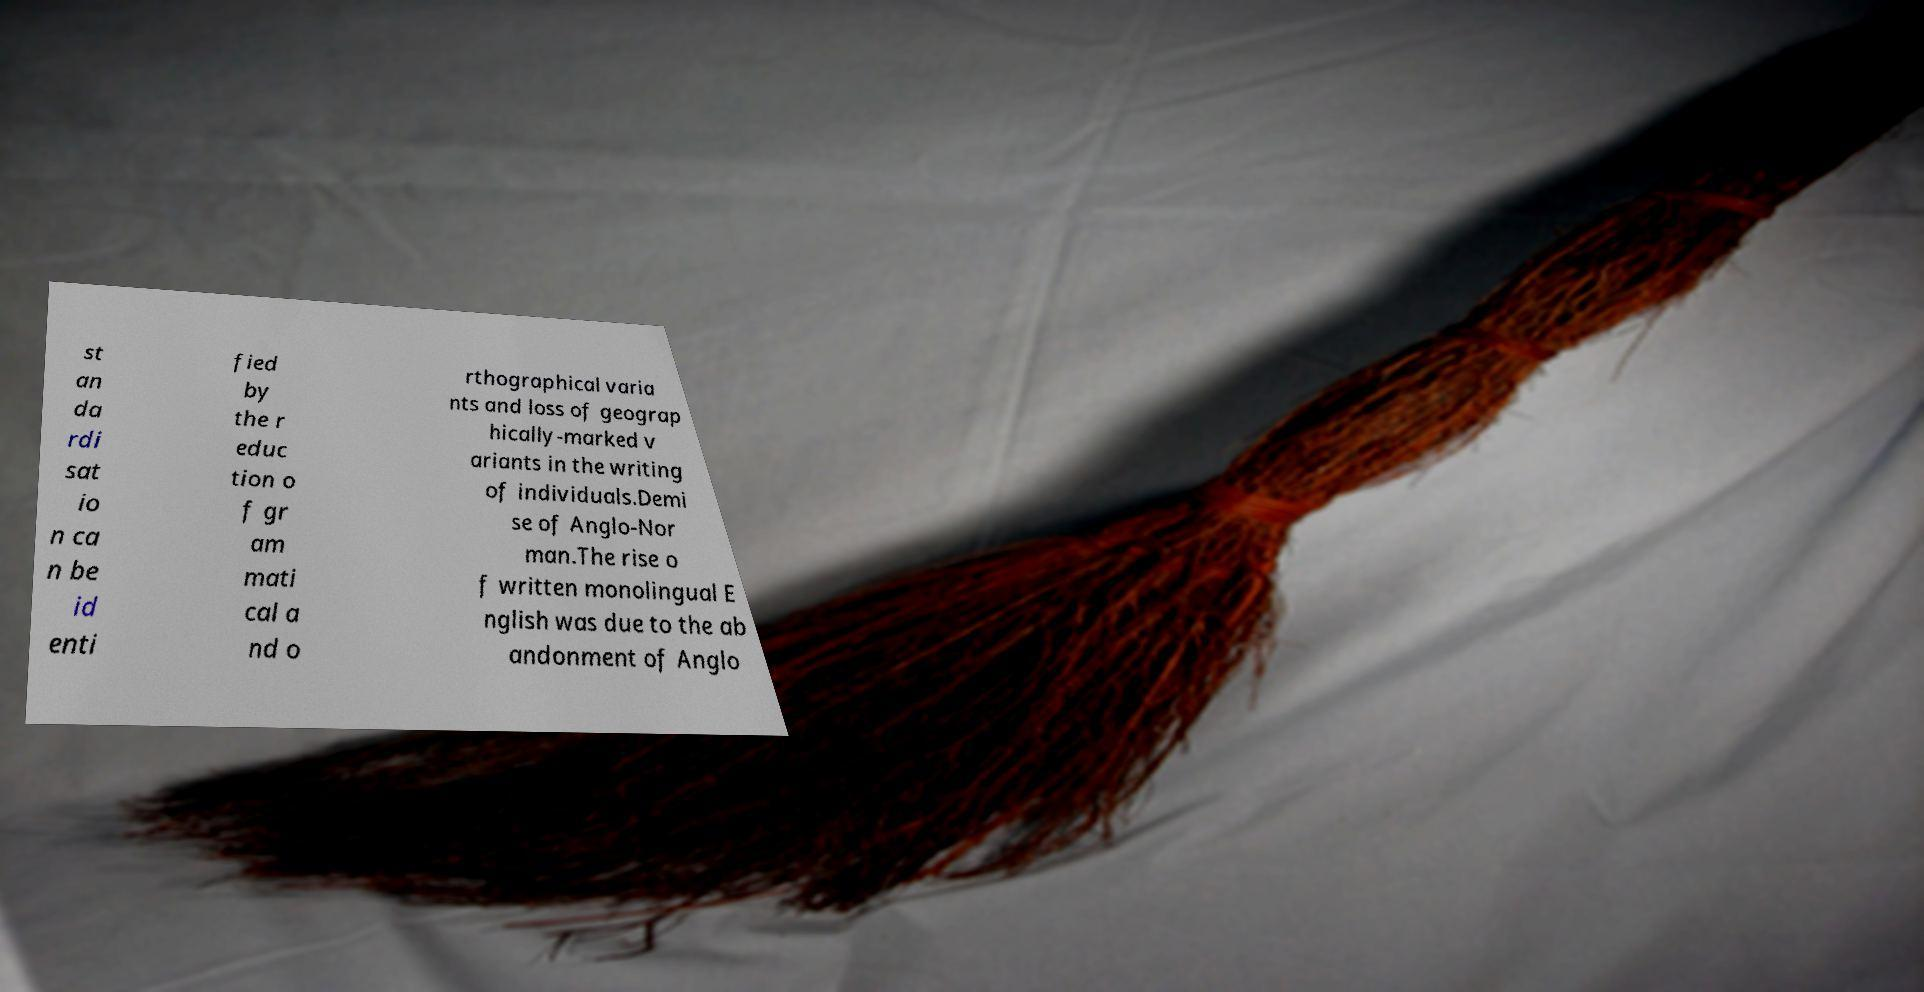What messages or text are displayed in this image? I need them in a readable, typed format. st an da rdi sat io n ca n be id enti fied by the r educ tion o f gr am mati cal a nd o rthographical varia nts and loss of geograp hically-marked v ariants in the writing of individuals.Demi se of Anglo-Nor man.The rise o f written monolingual E nglish was due to the ab andonment of Anglo 